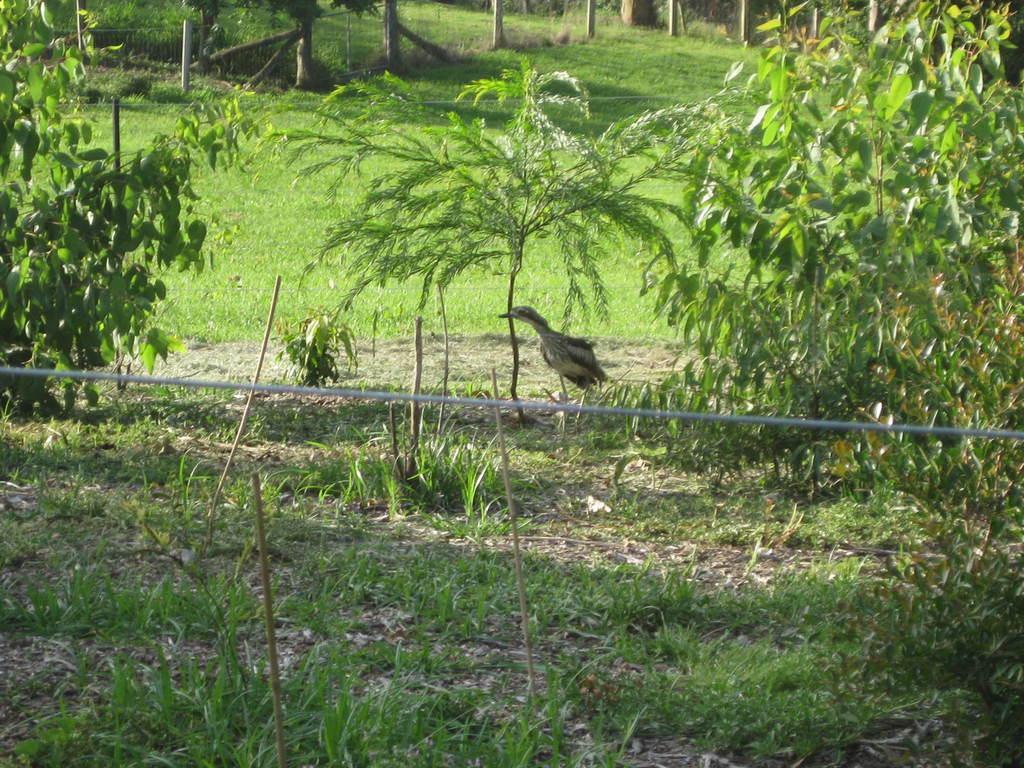Can you describe this image briefly? In this image we can see grass, plants and bird. 